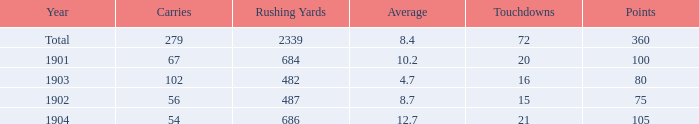What is the total number of rushing yards associated with averages over 8.4 and fewer than 54 carries? 0.0. 